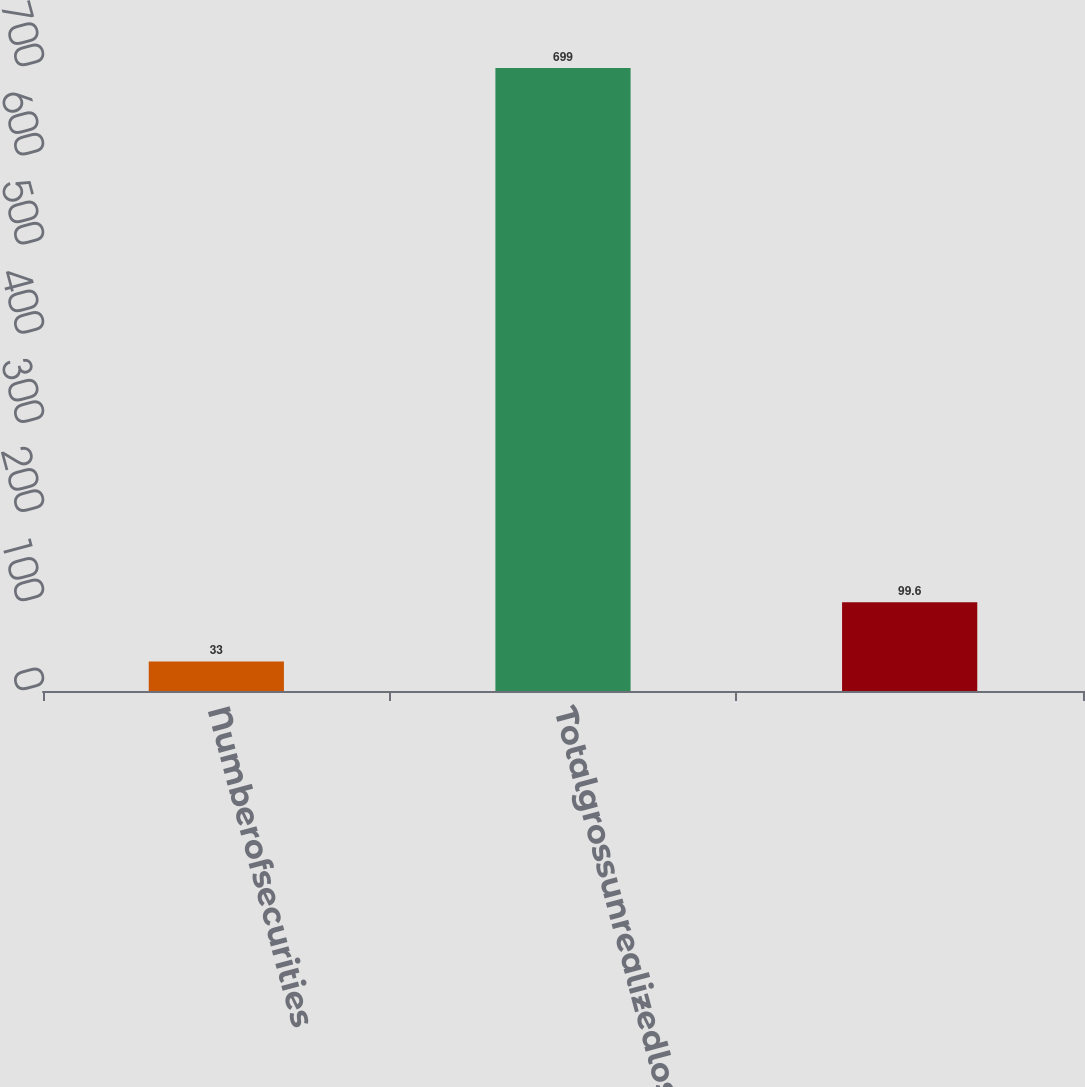Convert chart. <chart><loc_0><loc_0><loc_500><loc_500><bar_chart><fcel>Numberofsecurities<fcel>Totalgrossunrealizedloss<fcel>Unnamed: 2<nl><fcel>33<fcel>699<fcel>99.6<nl></chart> 